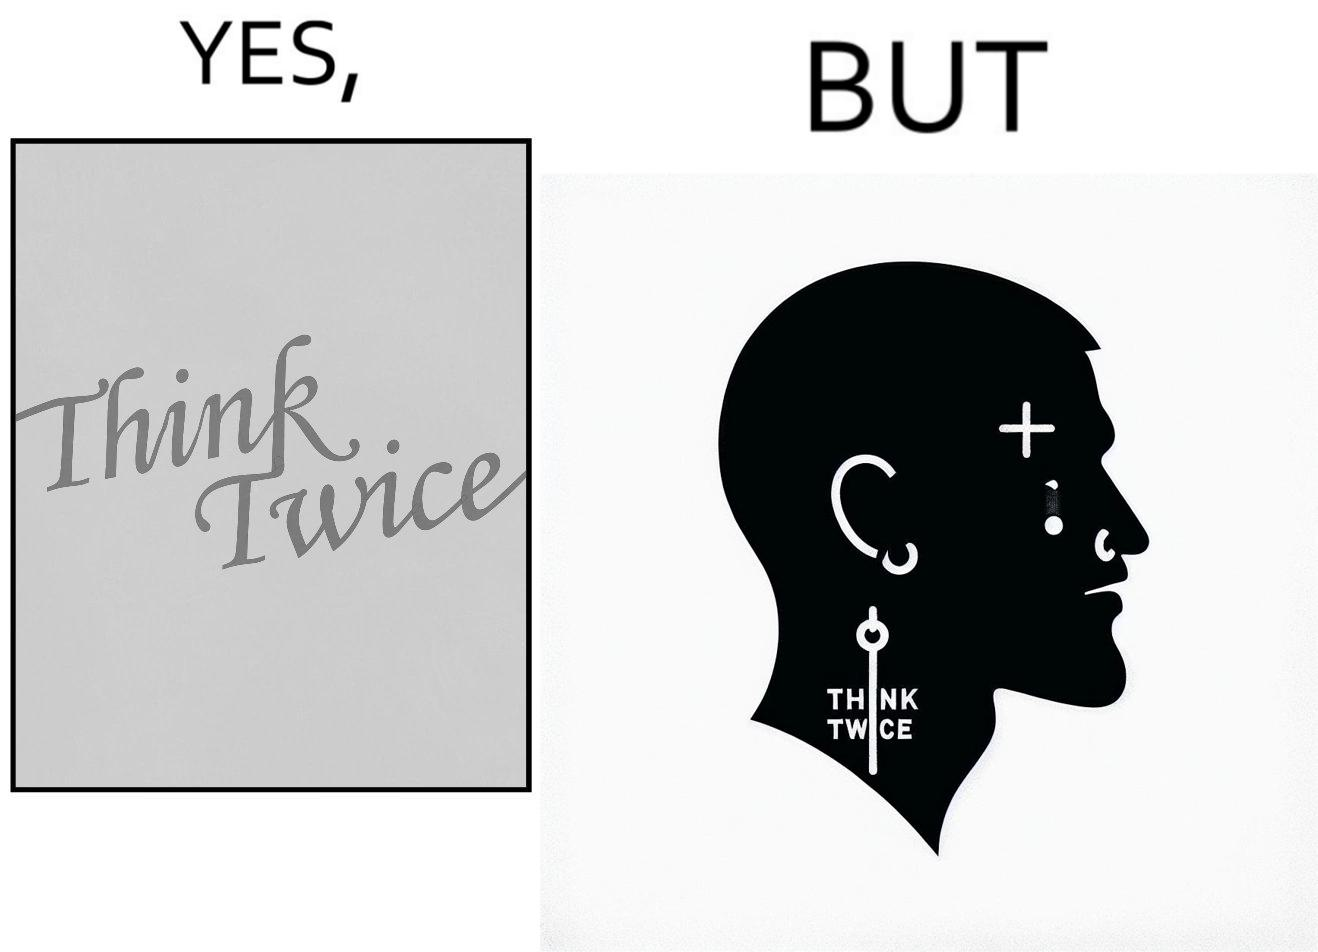Explain the humor or irony in this image. The image is funny because even thought the tattoo on the face of the man says "think twice", the man did not think twice before getting the tattoo on his forehead. 